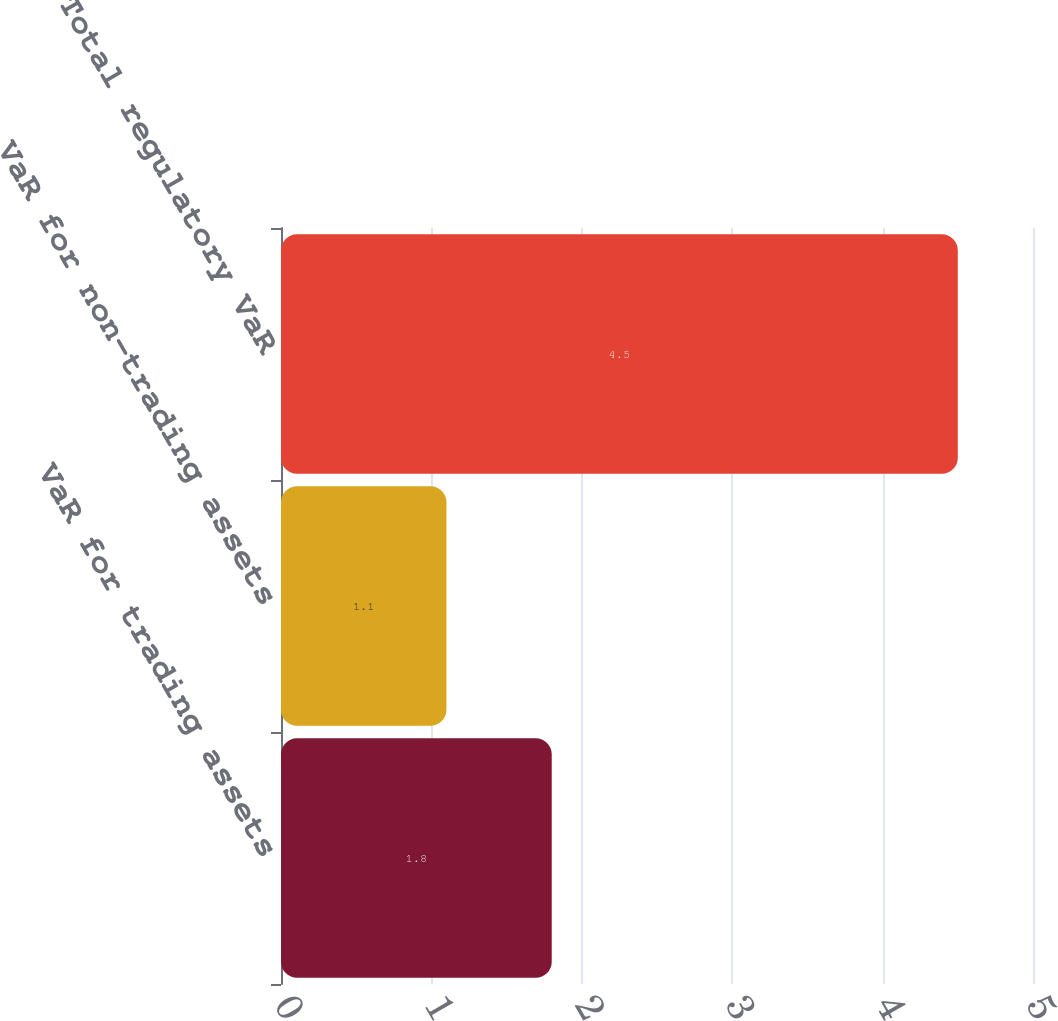Convert chart to OTSL. <chart><loc_0><loc_0><loc_500><loc_500><bar_chart><fcel>VaR for trading assets<fcel>VaR for non-trading assets<fcel>Total regulatory VaR<nl><fcel>1.8<fcel>1.1<fcel>4.5<nl></chart> 